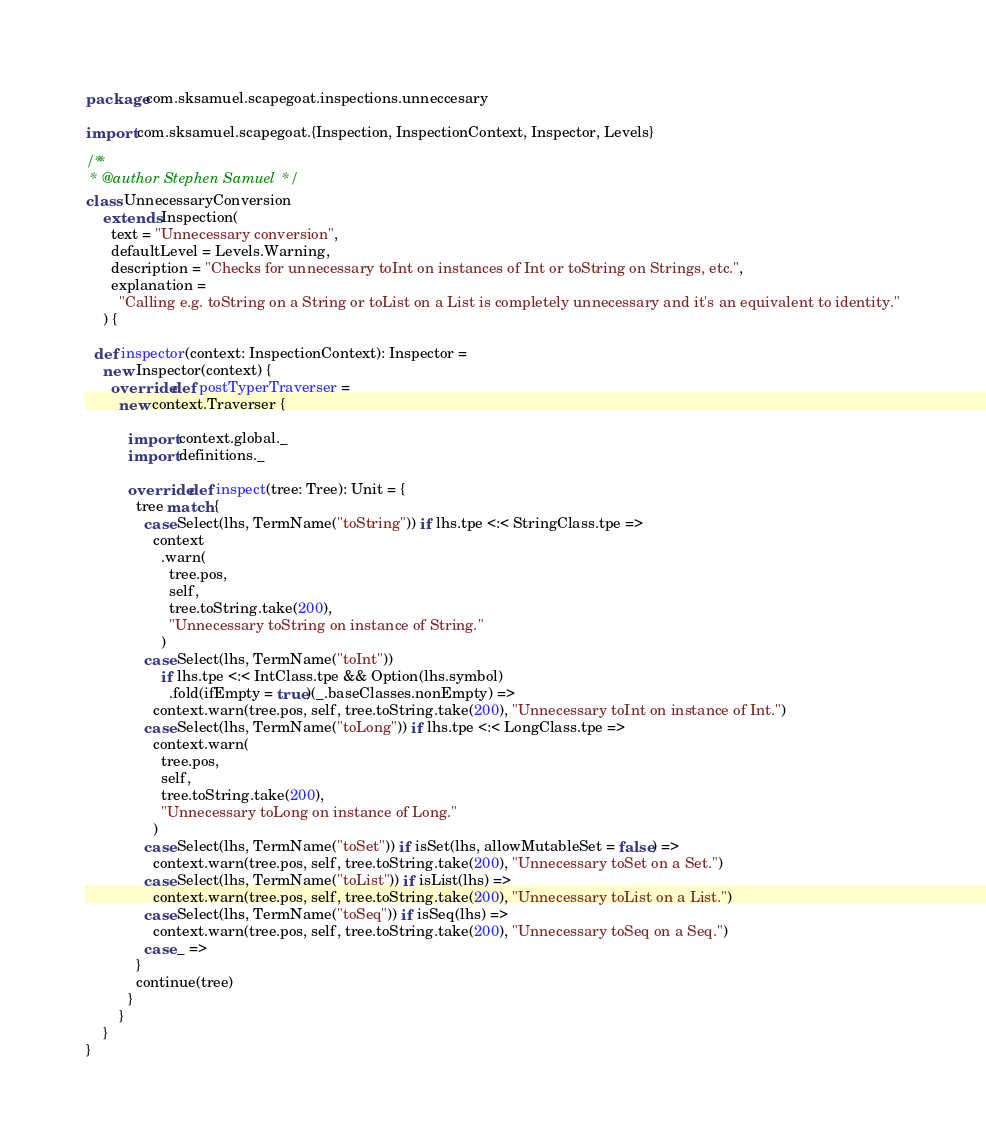Convert code to text. <code><loc_0><loc_0><loc_500><loc_500><_Scala_>package com.sksamuel.scapegoat.inspections.unneccesary

import com.sksamuel.scapegoat.{Inspection, InspectionContext, Inspector, Levels}

/**
 * @author Stephen Samuel */
class UnnecessaryConversion
    extends Inspection(
      text = "Unnecessary conversion",
      defaultLevel = Levels.Warning,
      description = "Checks for unnecessary toInt on instances of Int or toString on Strings, etc.",
      explanation =
        "Calling e.g. toString on a String or toList on a List is completely unnecessary and it's an equivalent to identity."
    ) {

  def inspector(context: InspectionContext): Inspector =
    new Inspector(context) {
      override def postTyperTraverser =
        new context.Traverser {

          import context.global._
          import definitions._

          override def inspect(tree: Tree): Unit = {
            tree match {
              case Select(lhs, TermName("toString")) if lhs.tpe <:< StringClass.tpe =>
                context
                  .warn(
                    tree.pos,
                    self,
                    tree.toString.take(200),
                    "Unnecessary toString on instance of String."
                  )
              case Select(lhs, TermName("toInt"))
                  if lhs.tpe <:< IntClass.tpe && Option(lhs.symbol)
                    .fold(ifEmpty = true)(_.baseClasses.nonEmpty) =>
                context.warn(tree.pos, self, tree.toString.take(200), "Unnecessary toInt on instance of Int.")
              case Select(lhs, TermName("toLong")) if lhs.tpe <:< LongClass.tpe =>
                context.warn(
                  tree.pos,
                  self,
                  tree.toString.take(200),
                  "Unnecessary toLong on instance of Long."
                )
              case Select(lhs, TermName("toSet")) if isSet(lhs, allowMutableSet = false) =>
                context.warn(tree.pos, self, tree.toString.take(200), "Unnecessary toSet on a Set.")
              case Select(lhs, TermName("toList")) if isList(lhs) =>
                context.warn(tree.pos, self, tree.toString.take(200), "Unnecessary toList on a List.")
              case Select(lhs, TermName("toSeq")) if isSeq(lhs) =>
                context.warn(tree.pos, self, tree.toString.take(200), "Unnecessary toSeq on a Seq.")
              case _ =>
            }
            continue(tree)
          }
        }
    }
}
</code> 